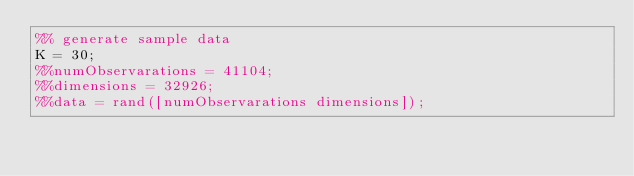<code> <loc_0><loc_0><loc_500><loc_500><_Matlab_>%% generate sample data
K = 30;
%%numObservarations = 41104;
%%dimensions = 32926;
%%data = rand([numObservarations dimensions]);</code> 